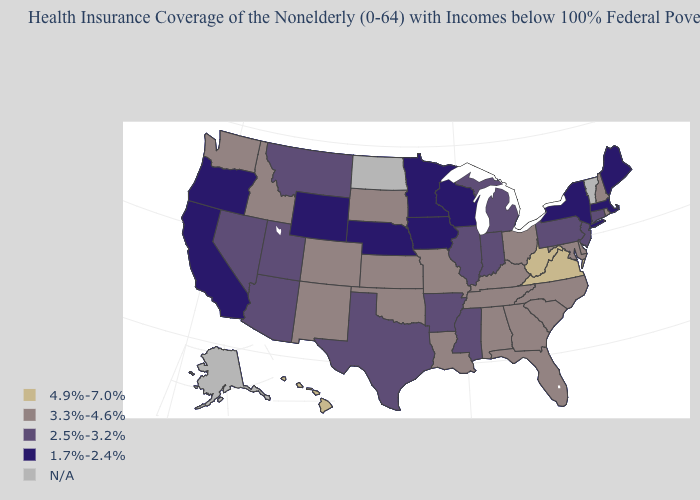What is the value of Virginia?
Be succinct. 4.9%-7.0%. Which states hav the highest value in the MidWest?
Concise answer only. Kansas, Missouri, Ohio, South Dakota. What is the value of Georgia?
Short answer required. 3.3%-4.6%. Which states have the lowest value in the USA?
Be succinct. California, Iowa, Maine, Massachusetts, Minnesota, Nebraska, New York, Oregon, Wisconsin, Wyoming. What is the value of New York?
Quick response, please. 1.7%-2.4%. Which states hav the highest value in the Northeast?
Keep it brief. New Hampshire, Rhode Island. What is the value of Montana?
Be succinct. 2.5%-3.2%. Does Tennessee have the lowest value in the South?
Write a very short answer. No. Does the map have missing data?
Give a very brief answer. Yes. What is the lowest value in the MidWest?
Answer briefly. 1.7%-2.4%. What is the highest value in the Northeast ?
Short answer required. 3.3%-4.6%. Name the states that have a value in the range 1.7%-2.4%?
Give a very brief answer. California, Iowa, Maine, Massachusetts, Minnesota, Nebraska, New York, Oregon, Wisconsin, Wyoming. 